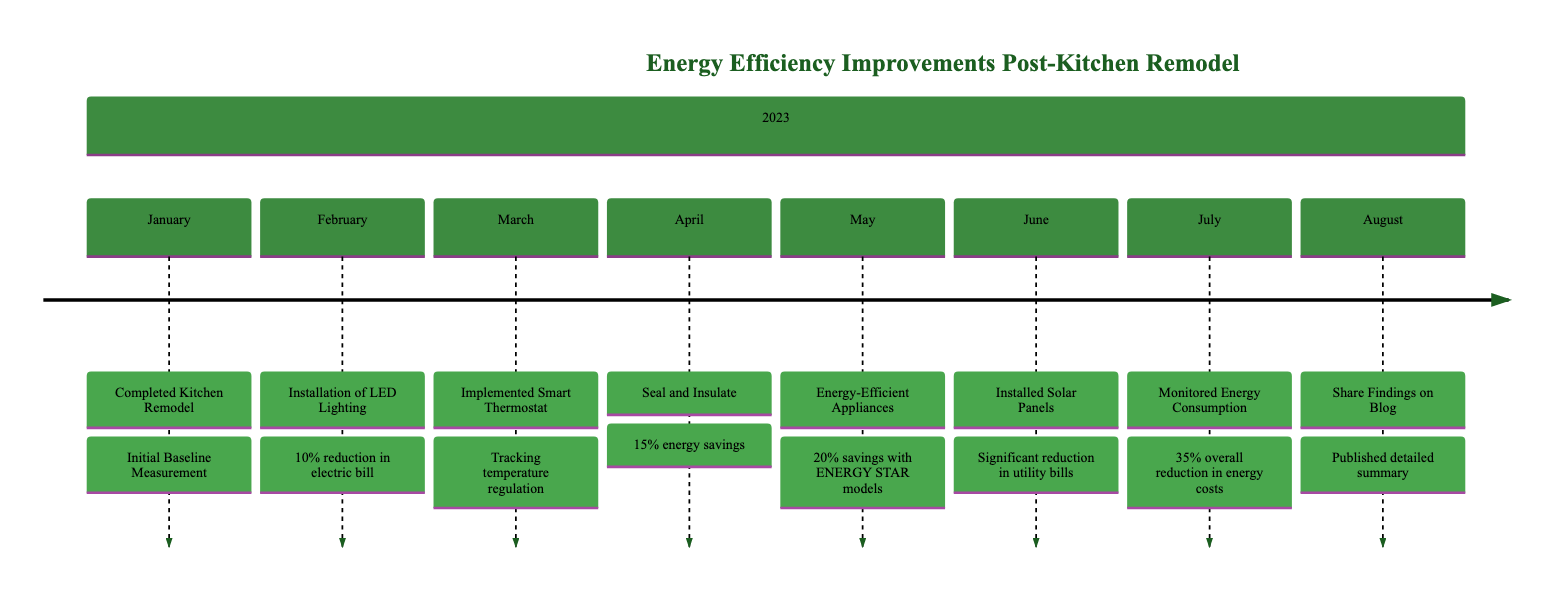What activity was completed in January? The diagram indicates that in January, the activity "Completed Kitchen Remodel" was recorded. This activity is the first point in the timeline and serves as the starting event.
Answer: Completed Kitchen Remodel What percentage reduction in electric bill was achieved in February? The diagram shows that after the installation of LED lighting in February, a 10% reduction in the electric bill was noted. This information is detailed in the second entry.
Answer: 10% How much energy savings was recorded in April? In April, after sealing and insulating, the diagram specifies that a 15% energy savings was achieved. This savings percentage is linked to the activities conducted that month.
Answer: 15% Which month featured the introduction of energy-efficient appliances? According to the timeline, the introduction of energy-efficient appliances was documented in May. This entry mentions swapping out older appliances for ENERGY STAR-rated models.
Answer: May What was the overall reduction in energy costs by July? The timeline indicates that by July, the overall reduction in energy costs documented was 35%. This value is recorded in the activity of monitoring energy consumption.
Answer: 35% In which month were solar panels installed? The diagram explicitly states that solar panels were installed in June. This activity marks a significant milestone towards renewable energy generation.
Answer: June What was shared on the blog in August? The timeline notes that in August, the activity involved sharing findings on the blog, particularly summarizing the energy efficiency improvements and savings achieved.
Answer: Published detailed summary What specific feature was implemented in March? The diagram specifies that in March, a smart thermostat was implemented, providing insights into temperature regulation and energy usage. This installation was aimed at monitoring energy consumption effectively.
Answer: Smart Thermostat In the timeline, how many activities were recorded in total? By counting the entries in the diagram, a total of eight distinct activities can be identified as going from January to August. Each month represents a specific activity or improvement.
Answer: 8 